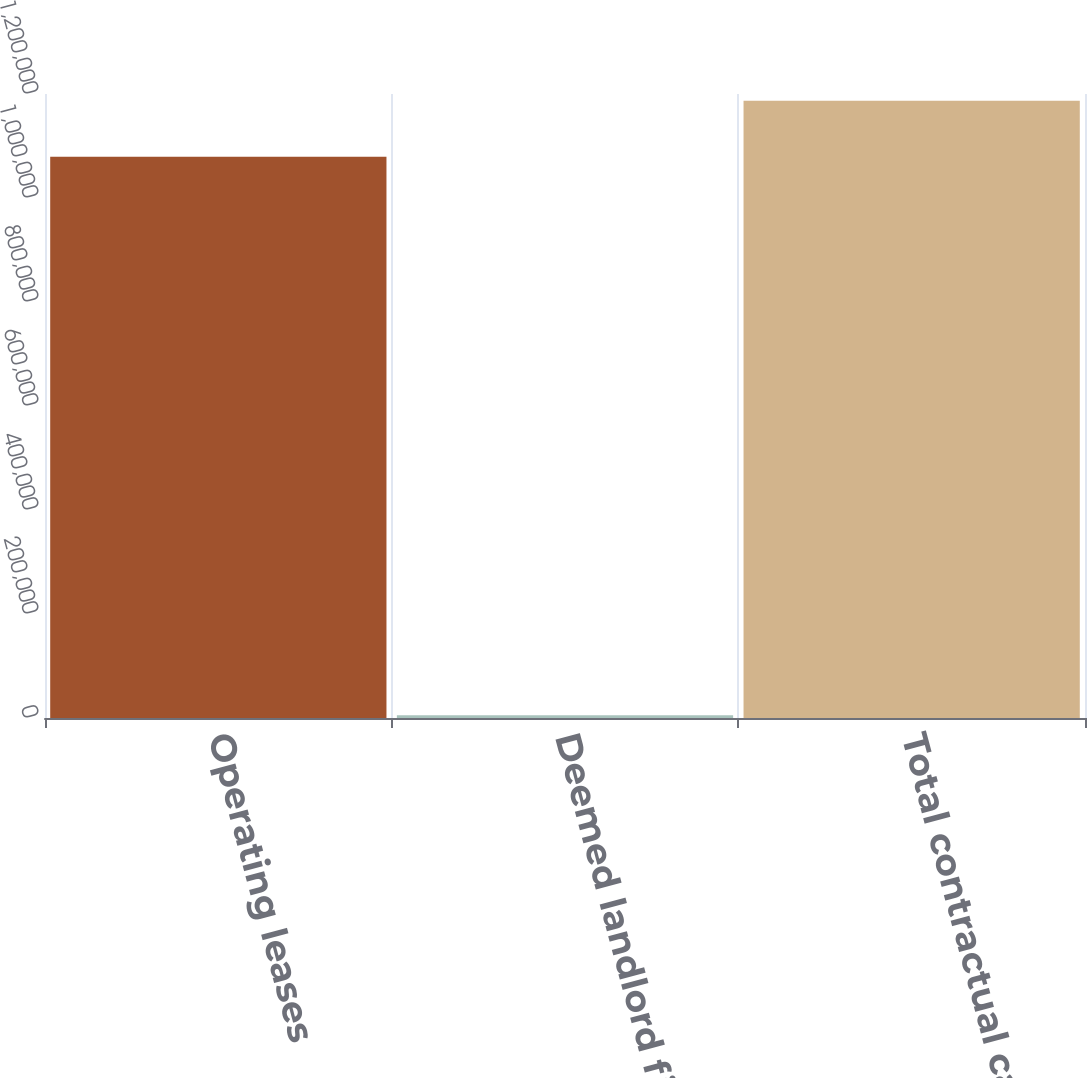<chart> <loc_0><loc_0><loc_500><loc_500><bar_chart><fcel>Operating leases<fcel>Deemed landlord financing<fcel>Total contractual cash<nl><fcel>1.07914e+06<fcel>5111<fcel>1.18705e+06<nl></chart> 